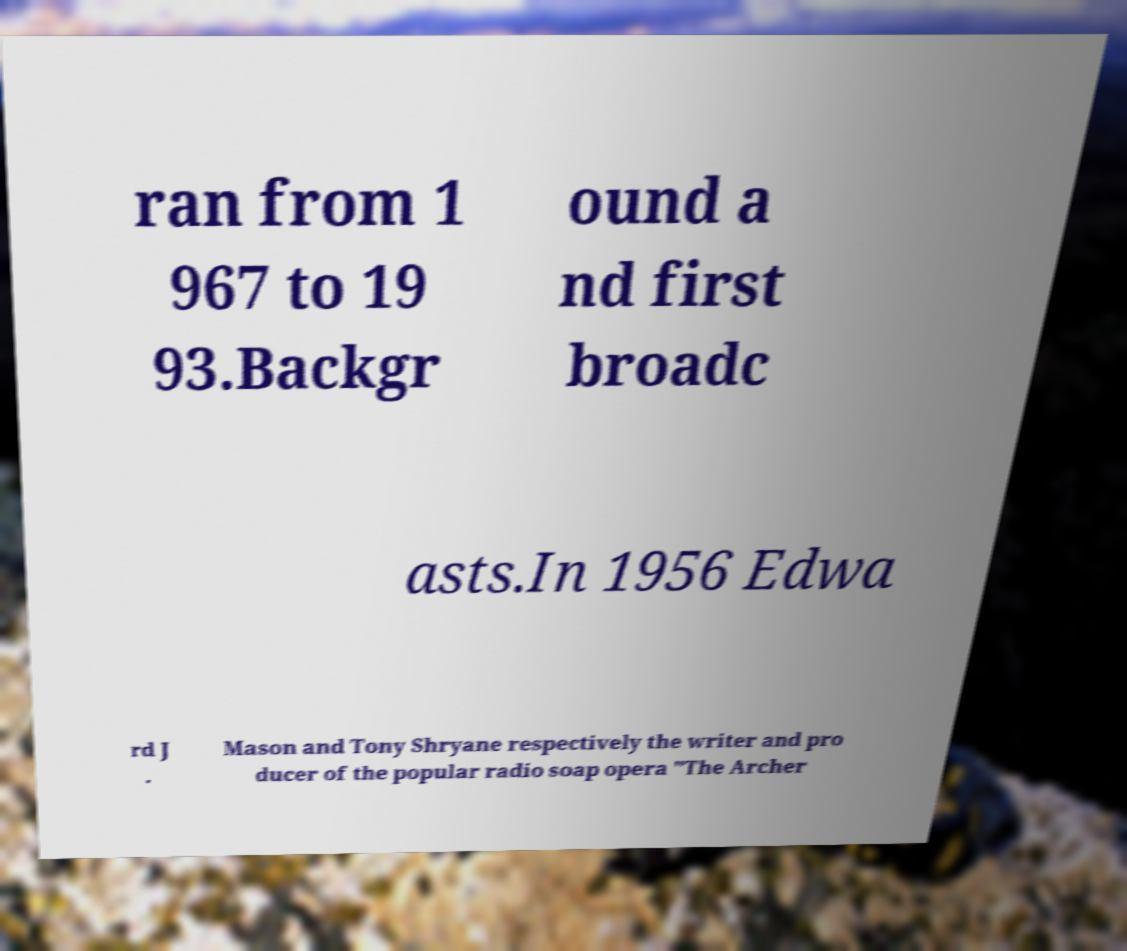What messages or text are displayed in this image? I need them in a readable, typed format. ran from 1 967 to 19 93.Backgr ound a nd first broadc asts.In 1956 Edwa rd J . Mason and Tony Shryane respectively the writer and pro ducer of the popular radio soap opera "The Archer 